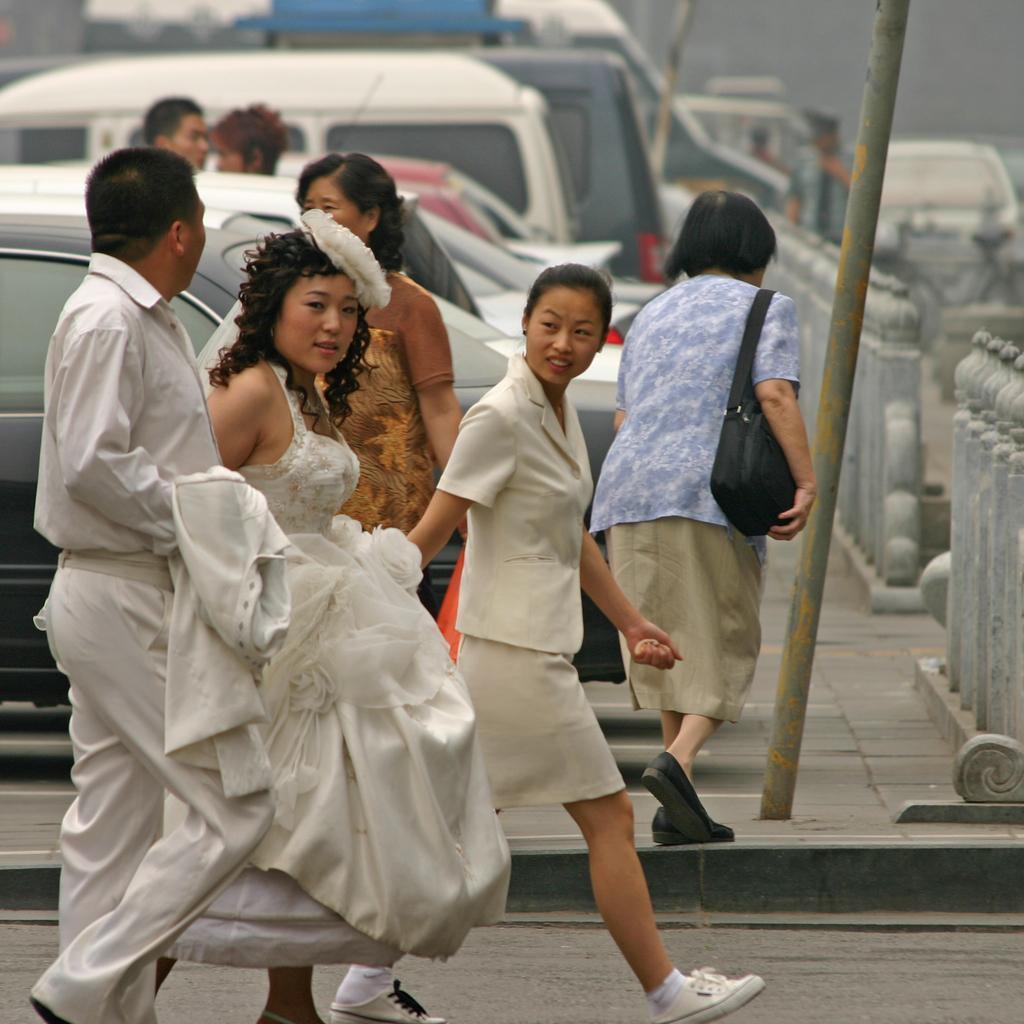Could you give a brief overview of what you see in this image? In this image we can see people, pole, vehicles and fencing. Front these people are walking. 